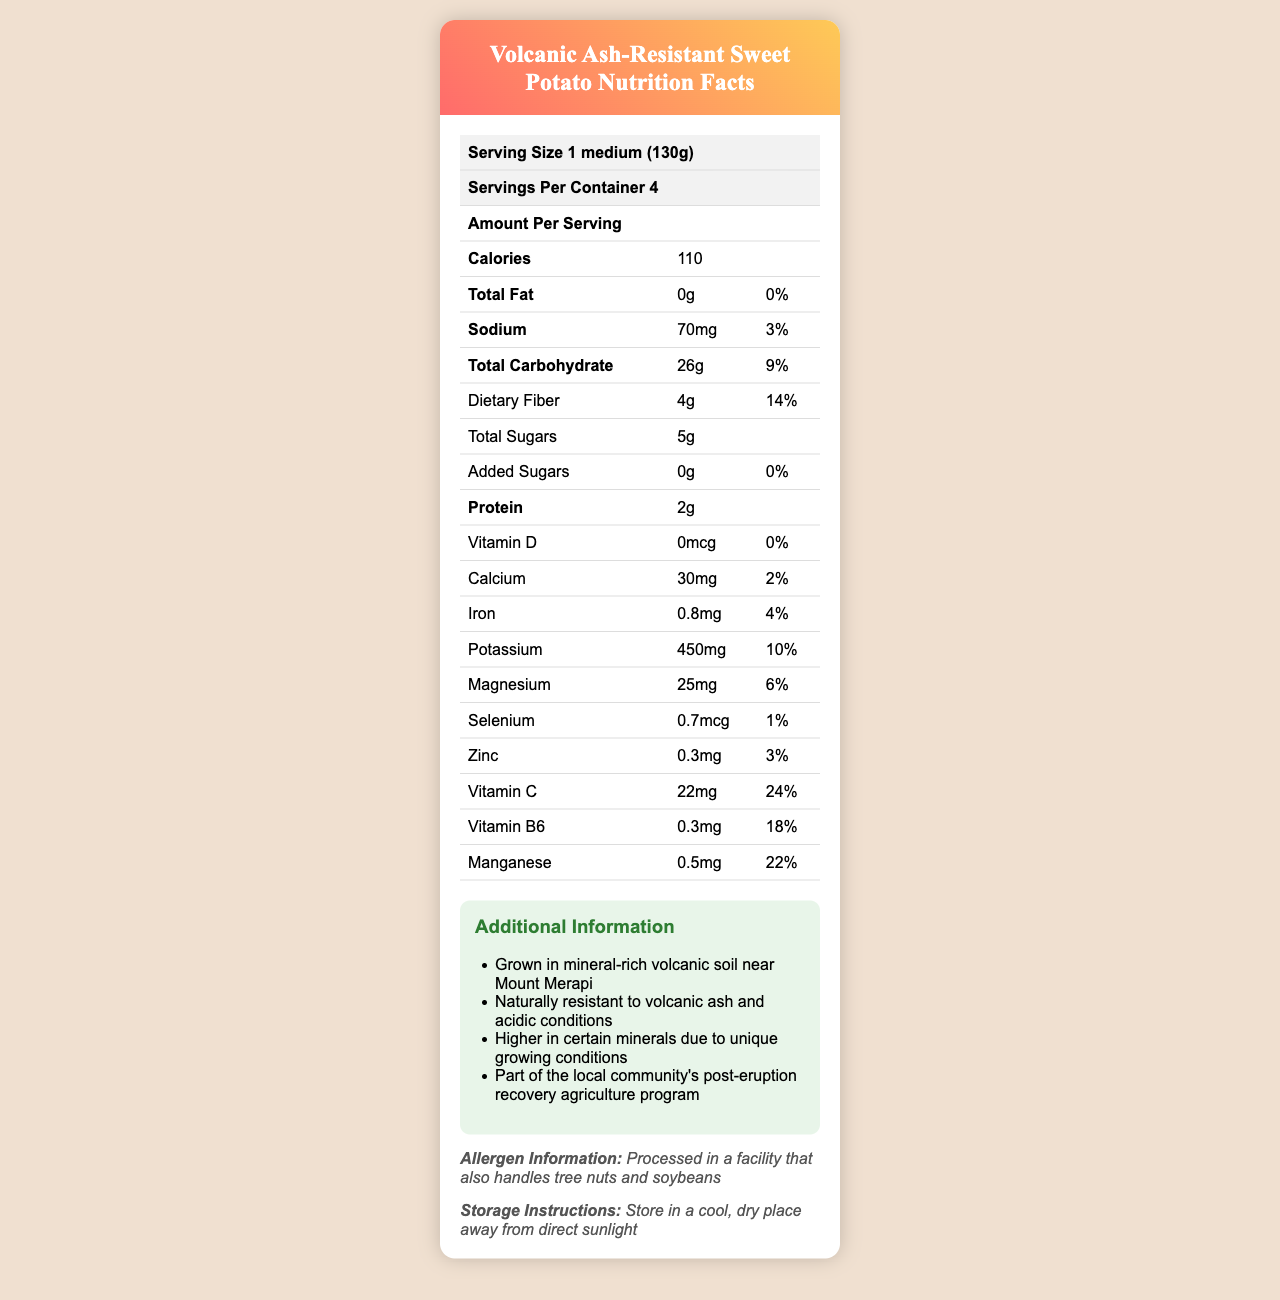how many calories are in a serving of Volcanic Ash-Resistant Sweet Potato? The document states that each serving of the sweet potato contains 110 calories.
Answer: 110 what amount of dietary fiber is in one serving? The nutrition facts indicate that there are 4 grams of dietary fiber per serving.
Answer: 4g how much sodium does one serving contain? The document specifies that there are 70 milligrams of sodium in one serving.
Answer: 70mg are there any added sugars in this product? According to the nutrition facts, the total amount of added sugars is 0 grams.
Answer: No what percentage of the daily value of vitamin C does one serving provide? The document shows that one serving provides 24% of the daily value for vitamin C.
Answer: 24% how much protein is in a serving? The nutrition facts state that there are 2 grams of protein in one serving.
Answer: 2g how many servings are in one container? The document mentions that there are 4 servings per container.
Answer: 4 which mineral has the highest daily value percentage in this product? A. Calcium B. Iron C. Potassium D. Magnesium E. Manganese Manganese has a daily value percentage of 22%, which is the highest among the listed options.
Answer: E what is the daily value percentage of Magnesium in one serving? A. 2% B. 4% C. 6% D. 10% The document specifies that the daily value percentage of Magnesium in one serving is 6%.
Answer: C is the food processed in a facility that handles common allergens? The allergen information confirms that the product is processed in a facility that also handles tree nuts and soybeans.
Answer: Yes does the product contain any vitamin D? The nutrition facts show that there is 0 micrograms of vitamin D, contributing to 0% of the daily value.
Answer: No describe the main information provided in the document This document offers comprehensive nutritional information and highlights that the sweet potatoes are grown in mineral-rich volcanic soil and are part of a local recovery agriculture program.
Answer: The document is a nutrition facts label for Volcanic Ash-Resistant Sweet Potato. It includes detailed nutritional information per serving (calories, fats, sodium, carbohydrates, proteins, vitamins, and minerals) and additional information like allergen data, storage instructions, and unique growing conditions. how much selenium is in a serving? According to the document, each serving contains 0.7 micrograms of selenium.
Answer: 0.7mcg what are the storage instructions for the Volcanic Ash-Resistant Sweet Potato? The storage instructions indicate the sweet potatoes should be kept in a cool, dry place away from direct sunlight.
Answer: Store in a cool, dry place away from direct sunlight what specific agricultural program is this product part of? The additional information mentions that these sweet potatoes are part of the local community's post-eruption recovery agriculture program.
Answer: Post-eruption recovery agriculture program does the amount of sugar include added sugars? The document clarifies that while there are 5 grams of total sugars, the amount of added sugars is 0 grams.
Answer: No how much potassium is there in one serving of the product? The nutrition facts indicate that one serving contains 450 milligrams of potassium.
Answer: 450mg is this product suitable for a low-sodium diet? While the sodium content is relatively low at 70mg (3% DV), whether it is suitable can depend on individual dietary needs and restrictions. More specific dietary information may be necessary.
Answer: It depends 